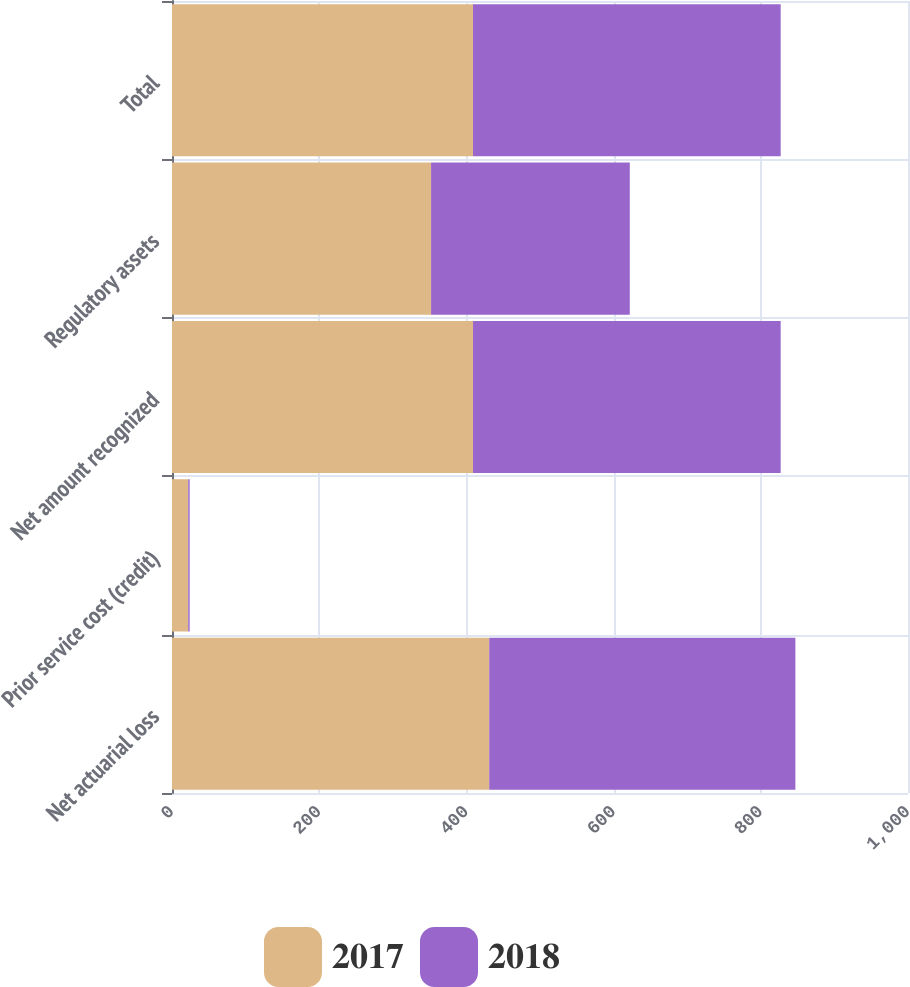<chart> <loc_0><loc_0><loc_500><loc_500><stacked_bar_chart><ecel><fcel>Net actuarial loss<fcel>Prior service cost (credit)<fcel>Net amount recognized<fcel>Regulatory assets<fcel>Total<nl><fcel>2017<fcel>431<fcel>22<fcel>409<fcel>352<fcel>409<nl><fcel>2018<fcel>416<fcel>2<fcel>418<fcel>270<fcel>418<nl></chart> 